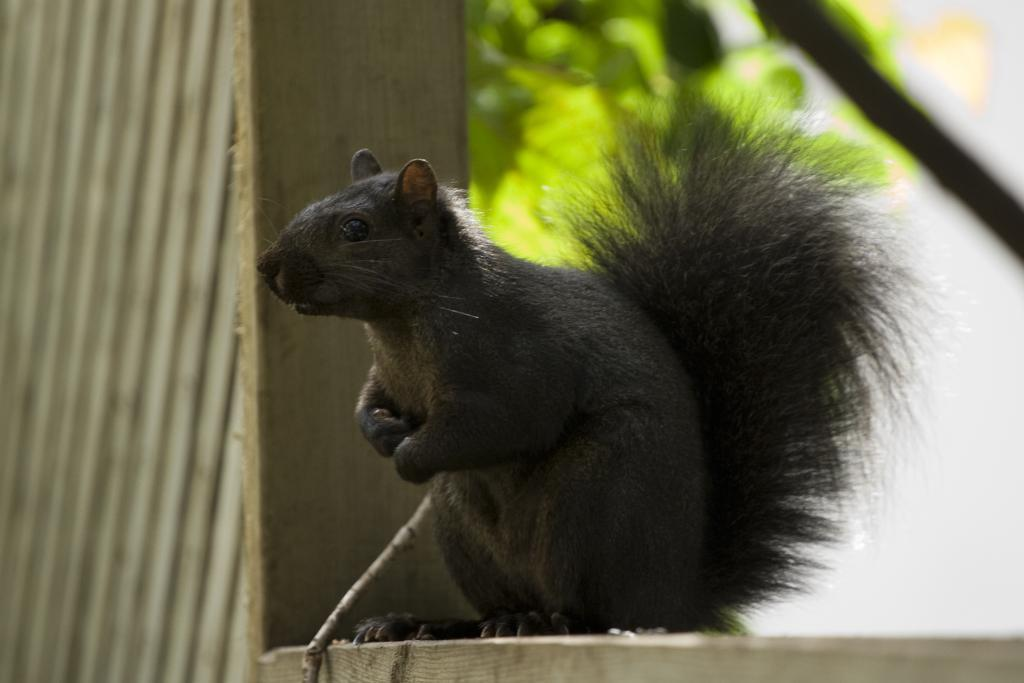What animal can be seen in the picture? There is a squirrel in the picture. Where is the squirrel located in the image? The squirrel is sitting on a wooden frame. What can be seen in the background of the picture? There are plants in the background of the picture. What is the squirrel's profit from sitting on the wooden frame in the image? There is no indication of profit in the image, as squirrels do not engage in profit-making activities. 